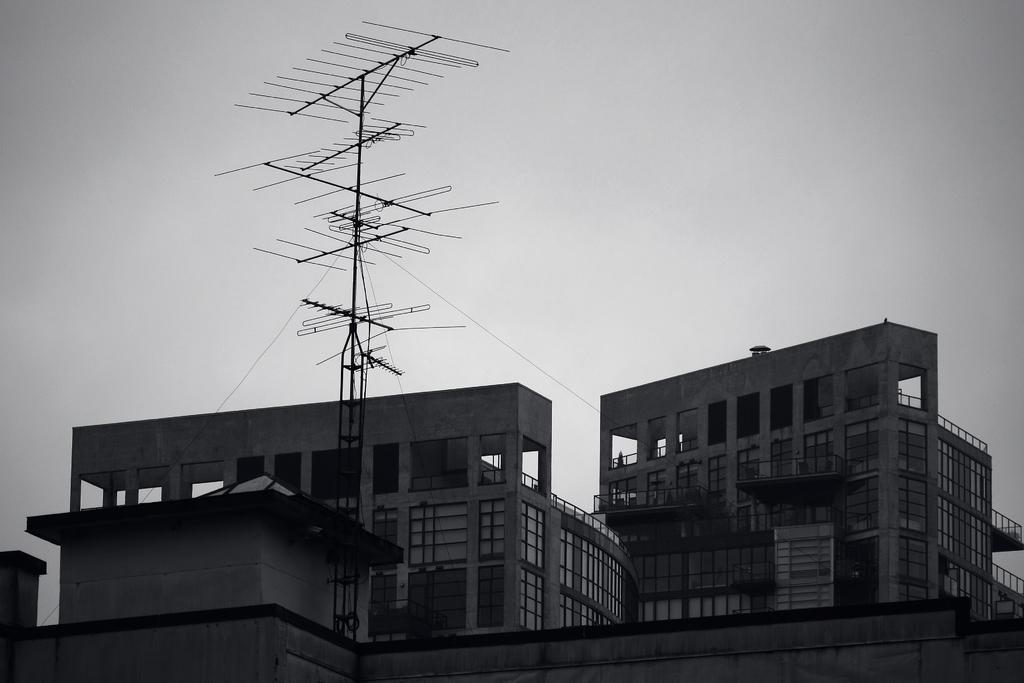What structures can be seen in the image? There are antennas and buildings in the image. What can be seen in the background of the image? The sky is visible in the image. What type of paste is being used to hold the buildings together in the image? There is no indication in the image that any paste is being used to hold the buildings together. 